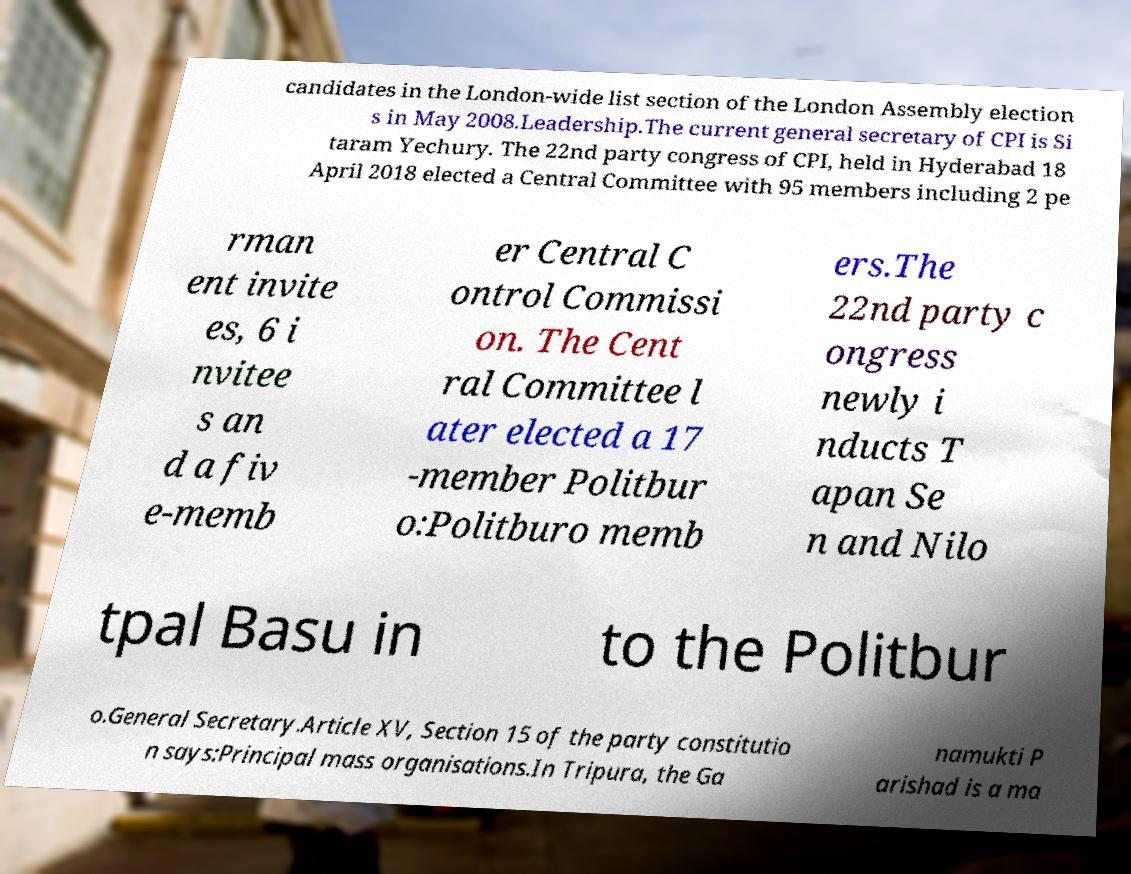Could you extract and type out the text from this image? candidates in the London-wide list section of the London Assembly election s in May 2008.Leadership.The current general secretary of CPI is Si taram Yechury. The 22nd party congress of CPI, held in Hyderabad 18 April 2018 elected a Central Committee with 95 members including 2 pe rman ent invite es, 6 i nvitee s an d a fiv e-memb er Central C ontrol Commissi on. The Cent ral Committee l ater elected a 17 -member Politbur o:Politburo memb ers.The 22nd party c ongress newly i nducts T apan Se n and Nilo tpal Basu in to the Politbur o.General Secretary.Article XV, Section 15 of the party constitutio n says:Principal mass organisations.In Tripura, the Ga namukti P arishad is a ma 